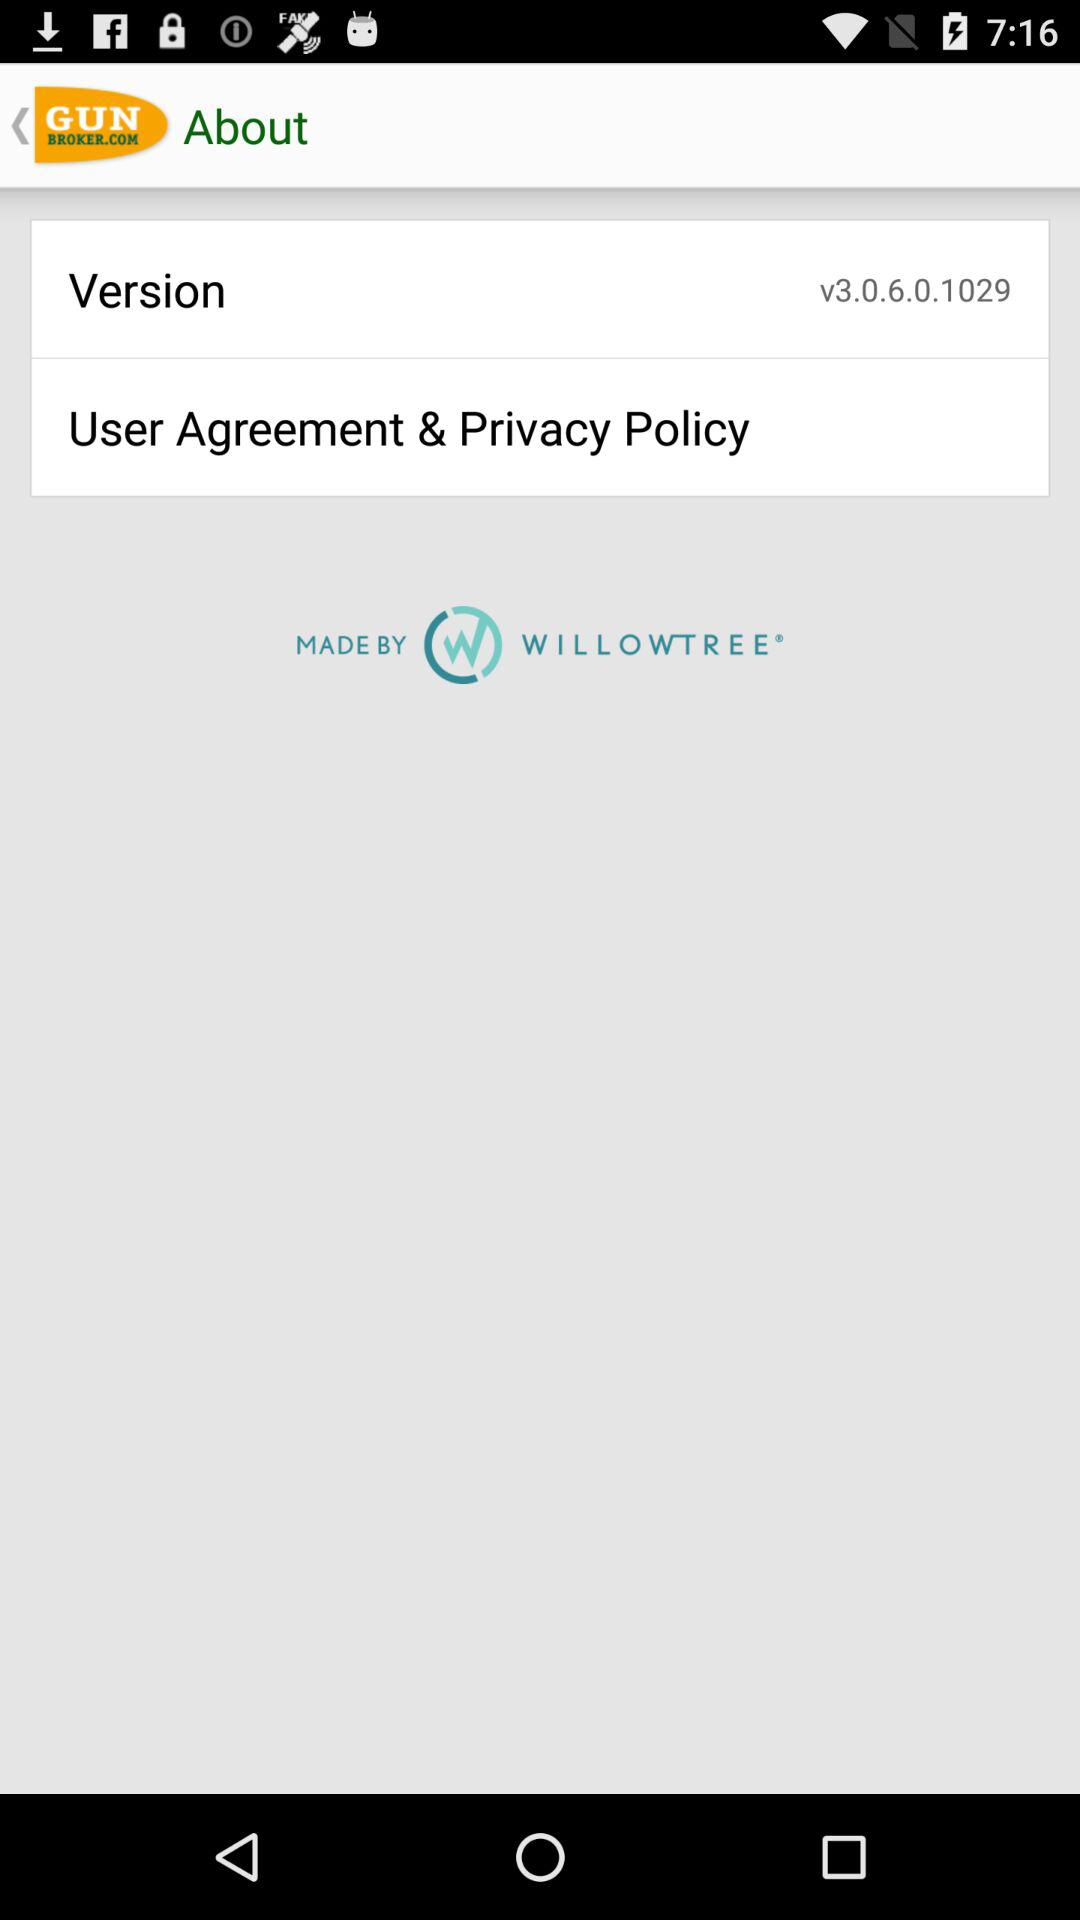What is the application name? The application name is "GUN BROKER.COM". 